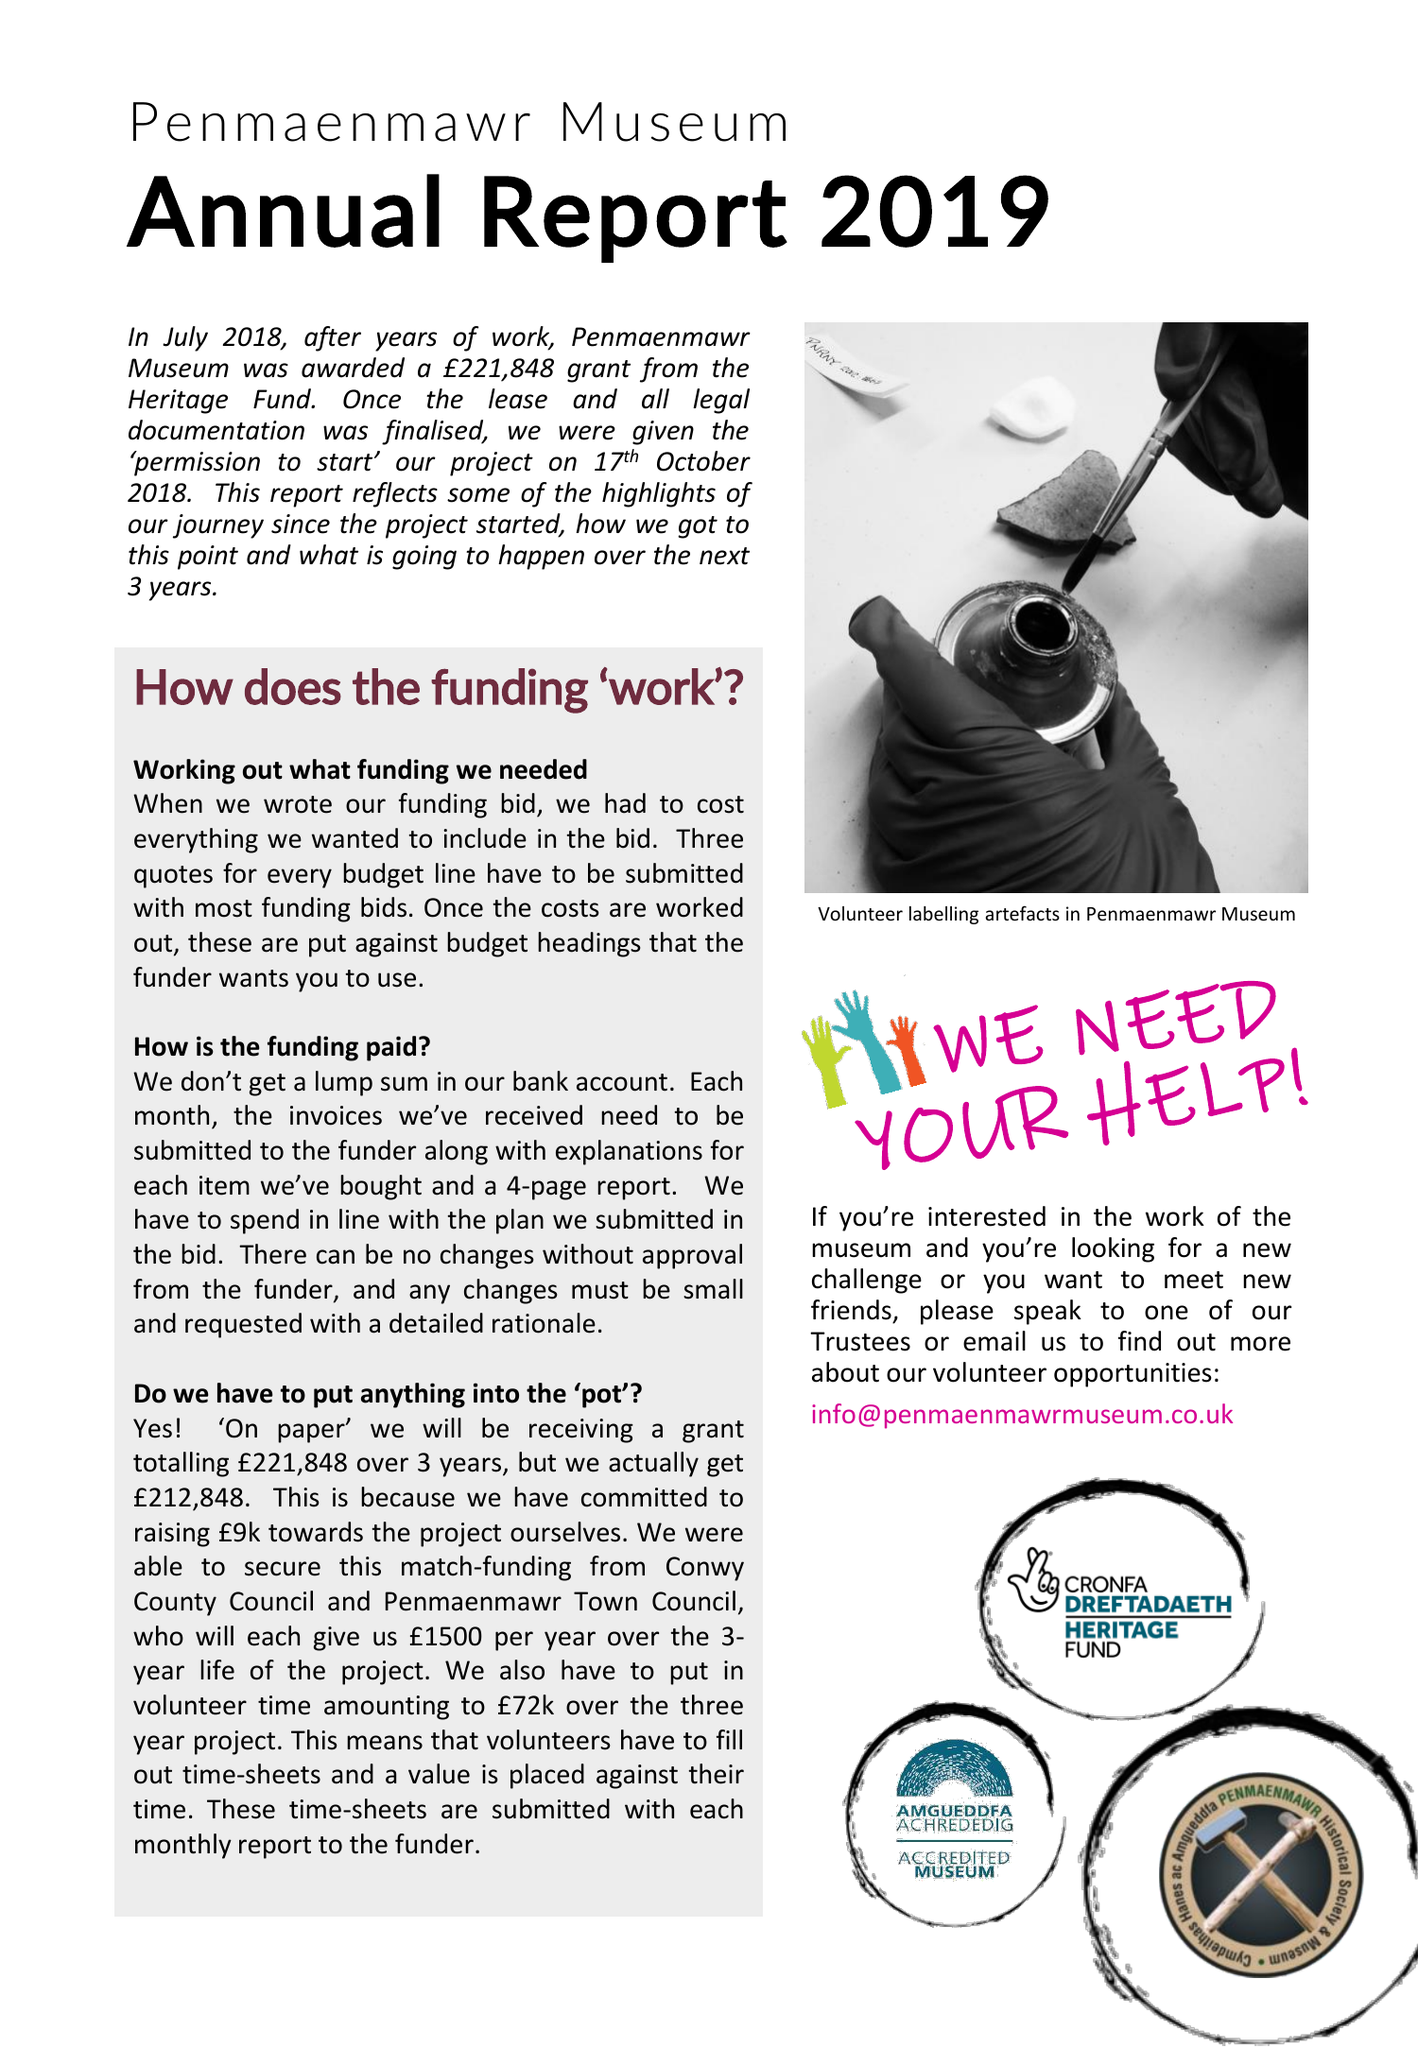What is the value for the income_annually_in_british_pounds?
Answer the question using a single word or phrase. 76332.00 